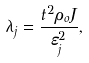Convert formula to latex. <formula><loc_0><loc_0><loc_500><loc_500>\lambda _ { j } = \frac { t ^ { 2 } \rho _ { o } J } { \varepsilon _ { j } ^ { 2 } } ,</formula> 